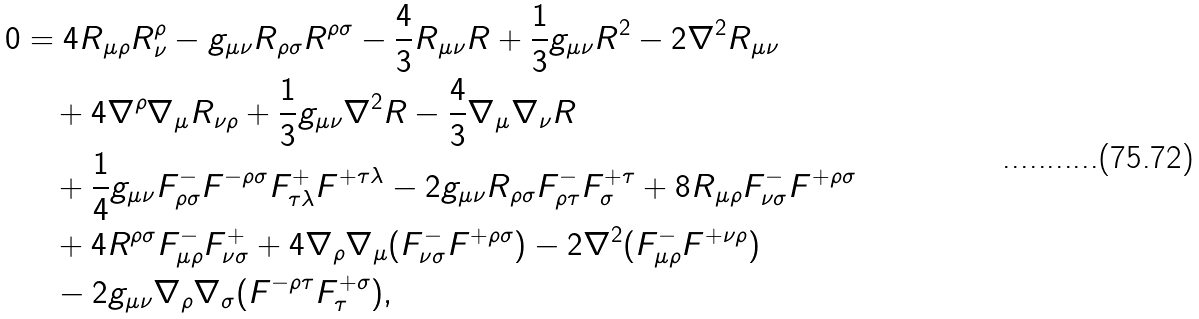<formula> <loc_0><loc_0><loc_500><loc_500>0 & = 4 R _ { \mu \rho } R _ { \nu } ^ { \rho } - g _ { \mu \nu } R _ { \rho \sigma } R ^ { \rho \sigma } - \frac { 4 } { 3 } R _ { \mu \nu } R + \frac { 1 } { 3 } g _ { \mu \nu } R ^ { 2 } - 2 \nabla ^ { 2 } R _ { \mu \nu } \\ & \quad + 4 \nabla ^ { \rho } \nabla _ { \mu } R _ { \nu \rho } + \frac { 1 } { 3 } g _ { \mu \nu } \nabla ^ { 2 } R - \frac { 4 } { 3 } \nabla _ { \mu } \nabla _ { \nu } R \\ & \quad + \frac { 1 } { 4 } g _ { \mu \nu } F ^ { - } _ { \rho \sigma } F ^ { - \rho \sigma } F ^ { + } _ { \tau \lambda } F ^ { + \tau \lambda } - 2 g _ { \mu \nu } R _ { \rho \sigma } F ^ { - } _ { \rho \tau } F ^ { + \tau } _ { \sigma } + 8 R _ { \mu \rho } F ^ { - } _ { \nu \sigma } F ^ { + \rho \sigma } \\ & \quad + 4 R ^ { \rho \sigma } F ^ { - } _ { \mu \rho } F ^ { + } _ { \nu \sigma } + 4 \nabla _ { \rho } \nabla _ { \mu } ( F ^ { - } _ { \nu \sigma } F ^ { + \rho \sigma } ) - 2 \nabla ^ { 2 } ( F ^ { - } _ { \mu \rho } F ^ { + \nu \rho } ) \\ & \quad - 2 g _ { \mu \nu } \nabla _ { \rho } \nabla _ { \sigma } ( F ^ { - \rho \tau } F ^ { + \sigma } _ { \tau } ) ,</formula> 